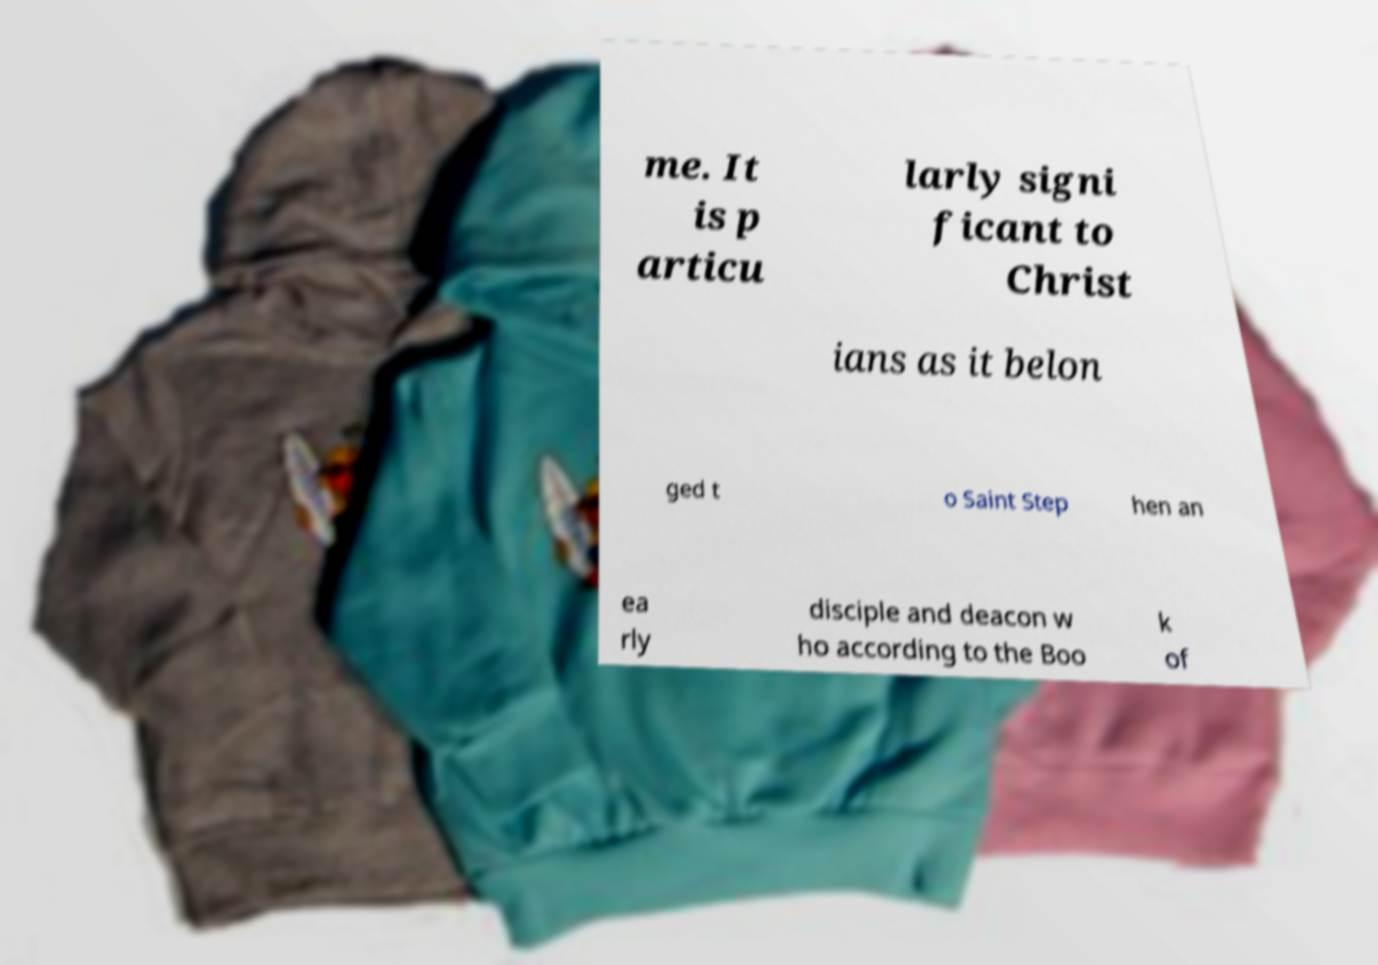Can you read and provide the text displayed in the image?This photo seems to have some interesting text. Can you extract and type it out for me? me. It is p articu larly signi ficant to Christ ians as it belon ged t o Saint Step hen an ea rly disciple and deacon w ho according to the Boo k of 